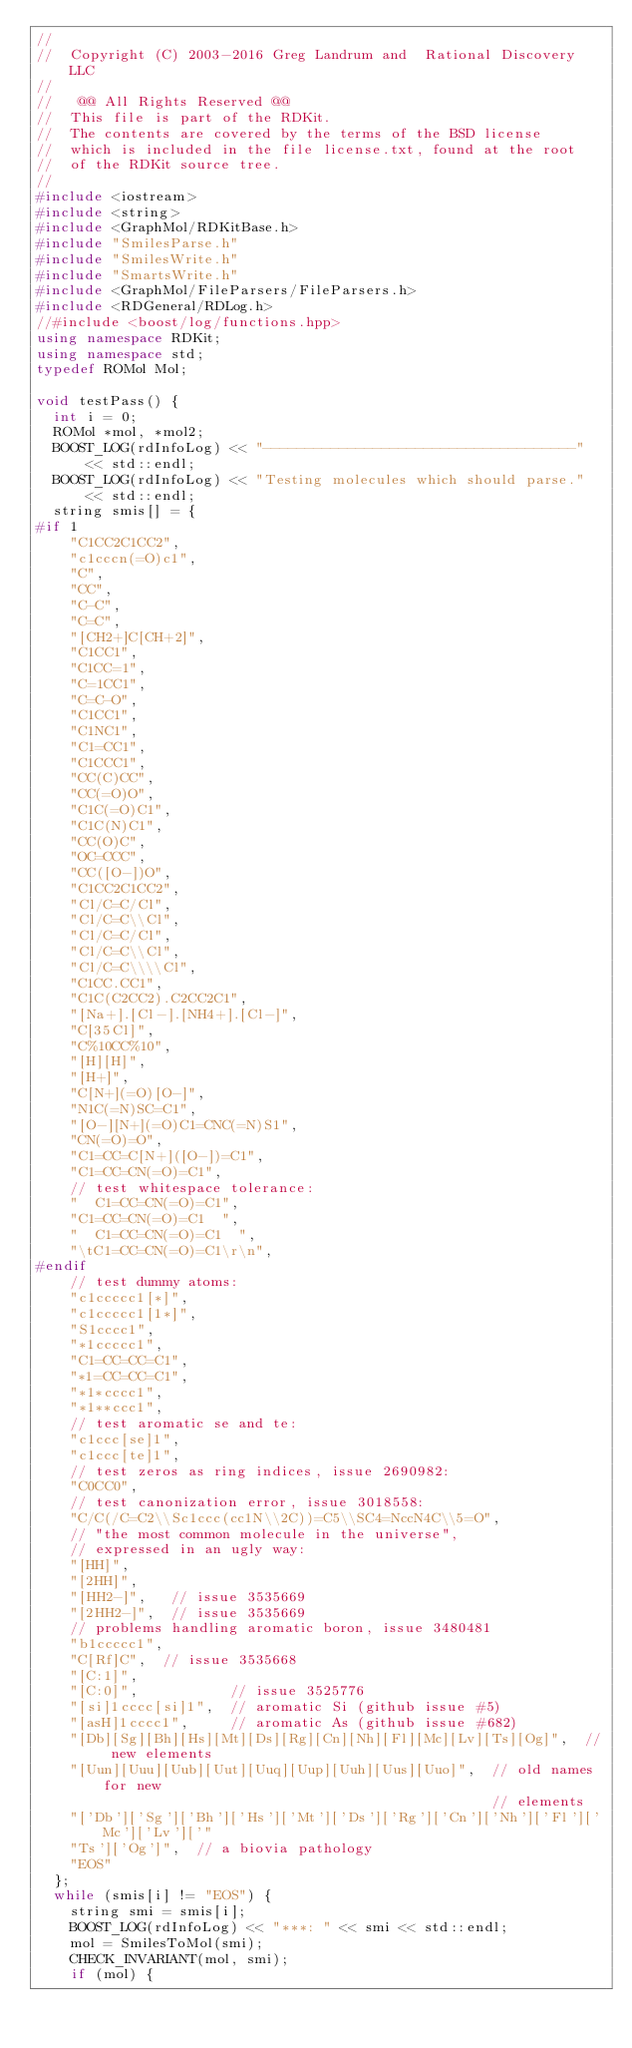Convert code to text. <code><loc_0><loc_0><loc_500><loc_500><_C++_>//
//  Copyright (C) 2003-2016 Greg Landrum and  Rational Discovery LLC
//
//   @@ All Rights Reserved @@
//  This file is part of the RDKit.
//  The contents are covered by the terms of the BSD license
//  which is included in the file license.txt, found at the root
//  of the RDKit source tree.
//
#include <iostream>
#include <string>
#include <GraphMol/RDKitBase.h>
#include "SmilesParse.h"
#include "SmilesWrite.h"
#include "SmartsWrite.h"
#include <GraphMol/FileParsers/FileParsers.h>
#include <RDGeneral/RDLog.h>
//#include <boost/log/functions.hpp>
using namespace RDKit;
using namespace std;
typedef ROMol Mol;

void testPass() {
  int i = 0;
  ROMol *mol, *mol2;
  BOOST_LOG(rdInfoLog) << "-------------------------------------" << std::endl;
  BOOST_LOG(rdInfoLog) << "Testing molecules which should parse." << std::endl;
  string smis[] = {
#if 1
    "C1CC2C1CC2",
    "c1cccn(=O)c1",
    "C",
    "CC",
    "C-C",
    "C=C",
    "[CH2+]C[CH+2]",
    "C1CC1",
    "C1CC=1",
    "C=1CC1",
    "C=C-O",
    "C1CC1",
    "C1NC1",
    "C1=CC1",
    "C1CCC1",
    "CC(C)CC",
    "CC(=O)O",
    "C1C(=O)C1",
    "C1C(N)C1",
    "CC(O)C",
    "OC=CCC",
    "CC([O-])O",
    "C1CC2C1CC2",
    "Cl/C=C/Cl",
    "Cl/C=C\\Cl",
    "Cl/C=C/Cl",
    "Cl/C=C\\Cl",
    "Cl/C=C\\\\Cl",
    "C1CC.CC1",
    "C1C(C2CC2).C2CC2C1",
    "[Na+].[Cl-].[NH4+].[Cl-]",
    "C[35Cl]",
    "C%10CC%10",
    "[H][H]",
    "[H+]",
    "C[N+](=O)[O-]",
    "N1C(=N)SC=C1",
    "[O-][N+](=O)C1=CNC(=N)S1",
    "CN(=O)=O",
    "C1=CC=C[N+]([O-])=C1",
    "C1=CC=CN(=O)=C1",
    // test whitespace tolerance:
    "  C1=CC=CN(=O)=C1",
    "C1=CC=CN(=O)=C1  ",
    "  C1=CC=CN(=O)=C1  ",
    "\tC1=CC=CN(=O)=C1\r\n",
#endif
    // test dummy atoms:
    "c1ccccc1[*]",
    "c1ccccc1[1*]",
    "S1cccc1",
    "*1ccccc1",
    "C1=CC=CC=C1",
    "*1=CC=CC=C1",
    "*1*cccc1",
    "*1**ccc1",
    // test aromatic se and te:
    "c1ccc[se]1",
    "c1ccc[te]1",
    // test zeros as ring indices, issue 2690982:
    "C0CC0",
    // test canonization error, issue 3018558:
    "C/C(/C=C2\\Sc1ccc(cc1N\\2C))=C5\\SC4=NccN4C\\5=O",
    // "the most common molecule in the universe",
    // expressed in an ugly way:
    "[HH]",
    "[2HH]",
    "[HH2-]",   // issue 3535669
    "[2HH2-]",  // issue 3535669
    // problems handling aromatic boron, issue 3480481
    "b1ccccc1",
    "C[Rf]C",  // issue 3535668
    "[C:1]",
    "[C:0]",           // issue 3525776
    "[si]1cccc[si]1",  // aromatic Si (github issue #5)
    "[asH]1cccc1",     // aromatic As (github issue #682)
    "[Db][Sg][Bh][Hs][Mt][Ds][Rg][Cn][Nh][Fl][Mc][Lv][Ts][Og]",  // new elements
    "[Uun][Uuu][Uub][Uut][Uuq][Uup][Uuh][Uus][Uuo]",  // old names for new
                                                      // elements
    "['Db']['Sg']['Bh']['Hs']['Mt']['Ds']['Rg']['Cn']['Nh']['Fl']['Mc']['Lv']['"
    "Ts']['Og']",  // a biovia pathology
    "EOS"
  };
  while (smis[i] != "EOS") {
    string smi = smis[i];
    BOOST_LOG(rdInfoLog) << "***: " << smi << std::endl;
    mol = SmilesToMol(smi);
    CHECK_INVARIANT(mol, smi);
    if (mol) {</code> 